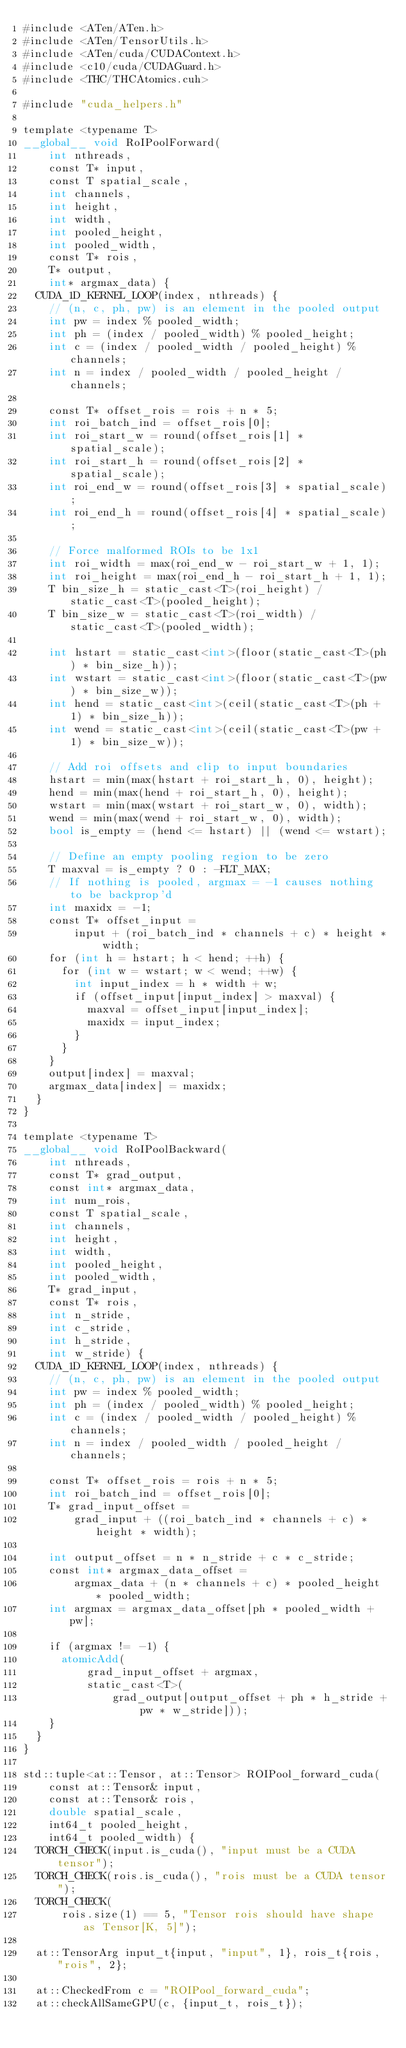Convert code to text. <code><loc_0><loc_0><loc_500><loc_500><_Cuda_>#include <ATen/ATen.h>
#include <ATen/TensorUtils.h>
#include <ATen/cuda/CUDAContext.h>
#include <c10/cuda/CUDAGuard.h>
#include <THC/THCAtomics.cuh>

#include "cuda_helpers.h"

template <typename T>
__global__ void RoIPoolForward(
    int nthreads,
    const T* input,
    const T spatial_scale,
    int channels,
    int height,
    int width,
    int pooled_height,
    int pooled_width,
    const T* rois,
    T* output,
    int* argmax_data) {
  CUDA_1D_KERNEL_LOOP(index, nthreads) {
    // (n, c, ph, pw) is an element in the pooled output
    int pw = index % pooled_width;
    int ph = (index / pooled_width) % pooled_height;
    int c = (index / pooled_width / pooled_height) % channels;
    int n = index / pooled_width / pooled_height / channels;

    const T* offset_rois = rois + n * 5;
    int roi_batch_ind = offset_rois[0];
    int roi_start_w = round(offset_rois[1] * spatial_scale);
    int roi_start_h = round(offset_rois[2] * spatial_scale);
    int roi_end_w = round(offset_rois[3] * spatial_scale);
    int roi_end_h = round(offset_rois[4] * spatial_scale);

    // Force malformed ROIs to be 1x1
    int roi_width = max(roi_end_w - roi_start_w + 1, 1);
    int roi_height = max(roi_end_h - roi_start_h + 1, 1);
    T bin_size_h = static_cast<T>(roi_height) / static_cast<T>(pooled_height);
    T bin_size_w = static_cast<T>(roi_width) / static_cast<T>(pooled_width);

    int hstart = static_cast<int>(floor(static_cast<T>(ph) * bin_size_h));
    int wstart = static_cast<int>(floor(static_cast<T>(pw) * bin_size_w));
    int hend = static_cast<int>(ceil(static_cast<T>(ph + 1) * bin_size_h));
    int wend = static_cast<int>(ceil(static_cast<T>(pw + 1) * bin_size_w));

    // Add roi offsets and clip to input boundaries
    hstart = min(max(hstart + roi_start_h, 0), height);
    hend = min(max(hend + roi_start_h, 0), height);
    wstart = min(max(wstart + roi_start_w, 0), width);
    wend = min(max(wend + roi_start_w, 0), width);
    bool is_empty = (hend <= hstart) || (wend <= wstart);

    // Define an empty pooling region to be zero
    T maxval = is_empty ? 0 : -FLT_MAX;
    // If nothing is pooled, argmax = -1 causes nothing to be backprop'd
    int maxidx = -1;
    const T* offset_input =
        input + (roi_batch_ind * channels + c) * height * width;
    for (int h = hstart; h < hend; ++h) {
      for (int w = wstart; w < wend; ++w) {
        int input_index = h * width + w;
        if (offset_input[input_index] > maxval) {
          maxval = offset_input[input_index];
          maxidx = input_index;
        }
      }
    }
    output[index] = maxval;
    argmax_data[index] = maxidx;
  }
}

template <typename T>
__global__ void RoIPoolBackward(
    int nthreads,
    const T* grad_output,
    const int* argmax_data,
    int num_rois,
    const T spatial_scale,
    int channels,
    int height,
    int width,
    int pooled_height,
    int pooled_width,
    T* grad_input,
    const T* rois,
    int n_stride,
    int c_stride,
    int h_stride,
    int w_stride) {
  CUDA_1D_KERNEL_LOOP(index, nthreads) {
    // (n, c, ph, pw) is an element in the pooled output
    int pw = index % pooled_width;
    int ph = (index / pooled_width) % pooled_height;
    int c = (index / pooled_width / pooled_height) % channels;
    int n = index / pooled_width / pooled_height / channels;

    const T* offset_rois = rois + n * 5;
    int roi_batch_ind = offset_rois[0];
    T* grad_input_offset =
        grad_input + ((roi_batch_ind * channels + c) * height * width);

    int output_offset = n * n_stride + c * c_stride;
    const int* argmax_data_offset =
        argmax_data + (n * channels + c) * pooled_height * pooled_width;
    int argmax = argmax_data_offset[ph * pooled_width + pw];

    if (argmax != -1) {
      atomicAdd(
          grad_input_offset + argmax,
          static_cast<T>(
              grad_output[output_offset + ph * h_stride + pw * w_stride]));
    }
  }
}

std::tuple<at::Tensor, at::Tensor> ROIPool_forward_cuda(
    const at::Tensor& input,
    const at::Tensor& rois,
    double spatial_scale,
    int64_t pooled_height,
    int64_t pooled_width) {
  TORCH_CHECK(input.is_cuda(), "input must be a CUDA tensor");
  TORCH_CHECK(rois.is_cuda(), "rois must be a CUDA tensor");
  TORCH_CHECK(
      rois.size(1) == 5, "Tensor rois should have shape as Tensor[K, 5]");

  at::TensorArg input_t{input, "input", 1}, rois_t{rois, "rois", 2};

  at::CheckedFrom c = "ROIPool_forward_cuda";
  at::checkAllSameGPU(c, {input_t, rois_t});</code> 